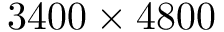<formula> <loc_0><loc_0><loc_500><loc_500>3 4 0 0 \times 4 8 0 0</formula> 